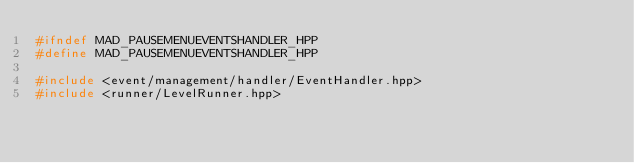<code> <loc_0><loc_0><loc_500><loc_500><_C++_>#ifndef MAD_PAUSEMENUEVENTSHANDLER_HPP
#define MAD_PAUSEMENUEVENTSHANDLER_HPP

#include <event/management/handler/EventHandler.hpp>
#include <runner/LevelRunner.hpp>
</code> 